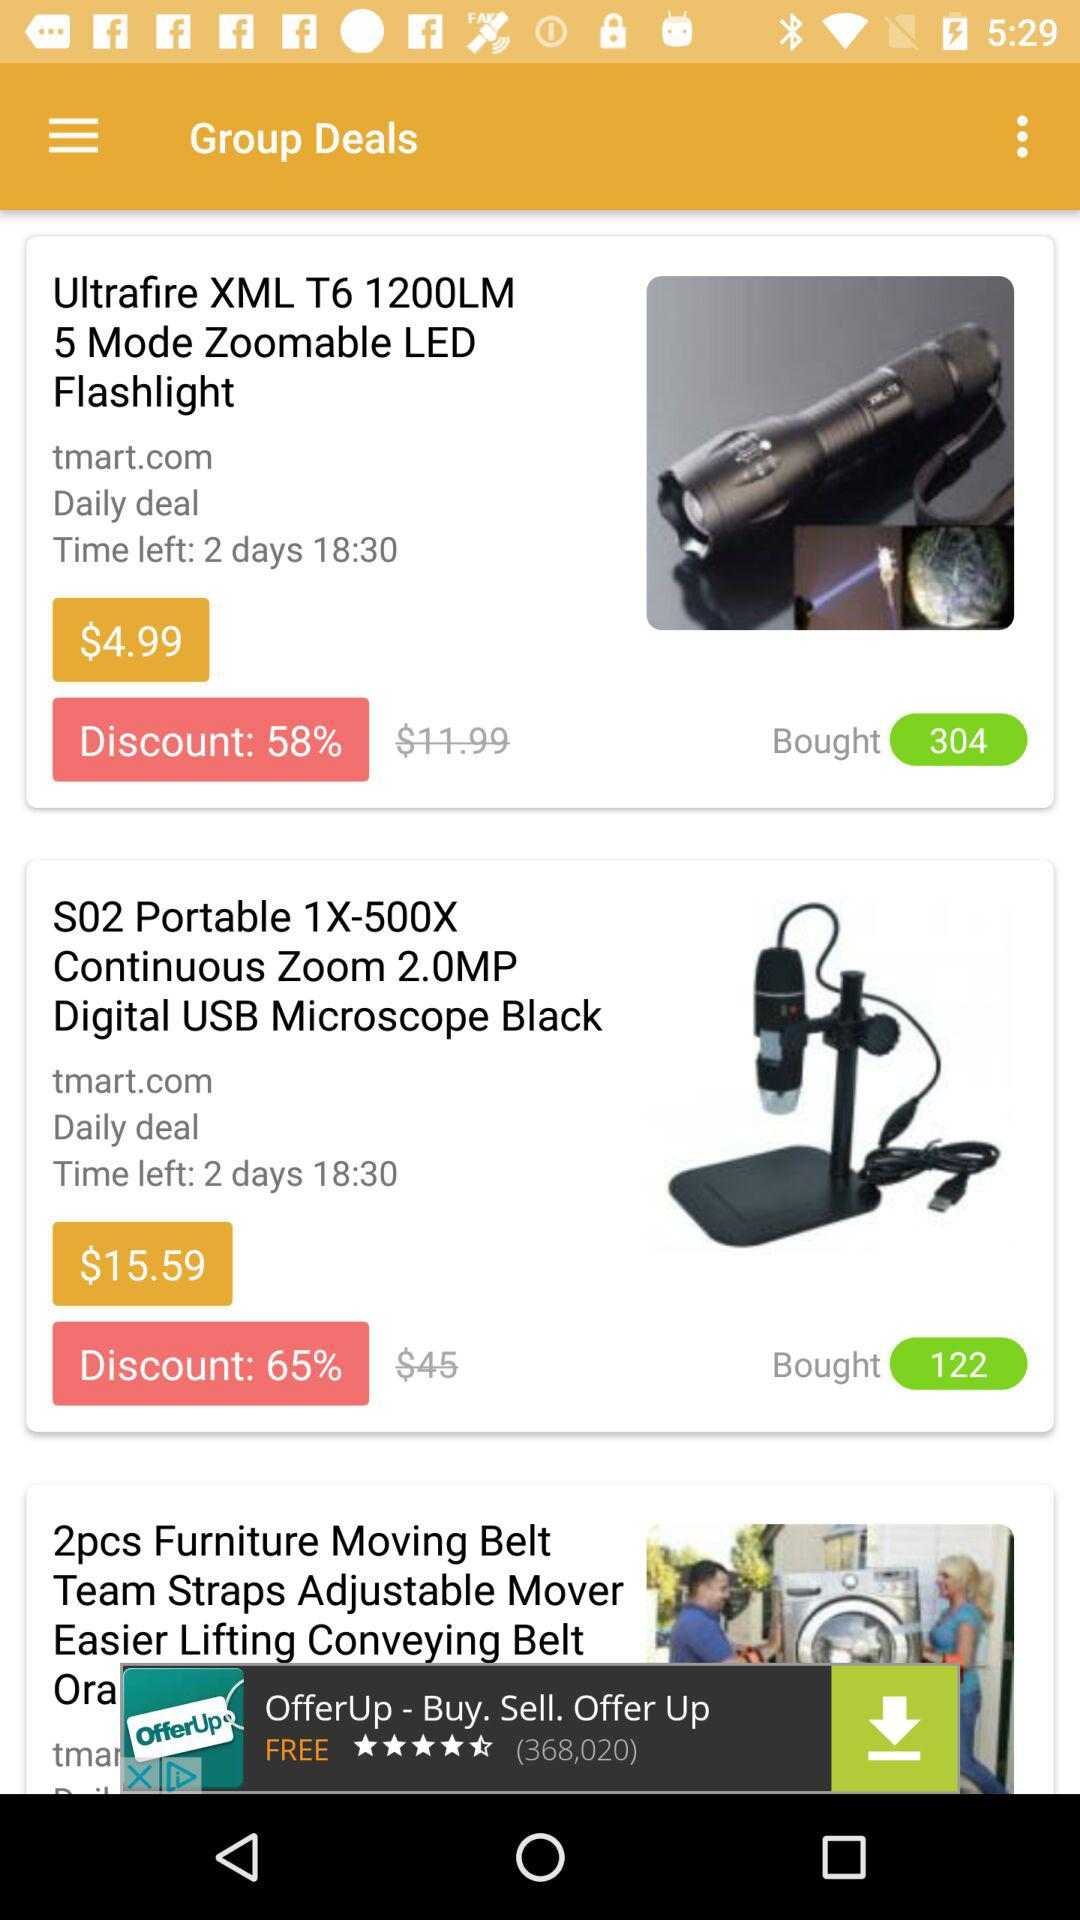What is the discount % on "S02 Portable 1X-500X"? The discount on "S02 Portable 1X-500X" is 65%. 